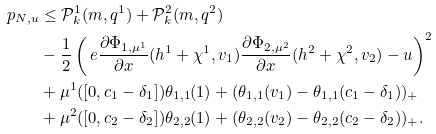Convert formula to latex. <formula><loc_0><loc_0><loc_500><loc_500>p _ { N , u } & \leq \mathcal { P } _ { k } ^ { 1 } ( m , q ^ { 1 } ) + \mathcal { P } _ { k } ^ { 2 } ( m , q ^ { 2 } ) \\ & - \frac { 1 } { 2 } \left ( \ e \frac { \partial \Phi _ { 1 , \mu ^ { 1 } } } { \partial x } ( h ^ { 1 } + \chi ^ { 1 } , v _ { 1 } ) \frac { \partial \Phi _ { 2 , \mu ^ { 2 } } } { \partial x } ( h ^ { 2 } + \chi ^ { 2 } , v _ { 2 } ) - u \right ) ^ { 2 } \\ & + \mu ^ { 1 } ( [ 0 , c _ { 1 } - \delta _ { 1 } ] ) \theta _ { 1 , 1 } ( 1 ) + ( \theta _ { 1 , 1 } ( v _ { 1 } ) - \theta _ { 1 , 1 } ( c _ { 1 } - \delta _ { 1 } ) ) _ { + } \\ & + \mu ^ { 2 } ( [ 0 , c _ { 2 } - \delta _ { 2 } ] ) \theta _ { 2 , 2 } ( 1 ) + ( \theta _ { 2 , 2 } ( v _ { 2 } ) - \theta _ { 2 , 2 } ( c _ { 2 } - \delta _ { 2 } ) ) _ { + } .</formula> 